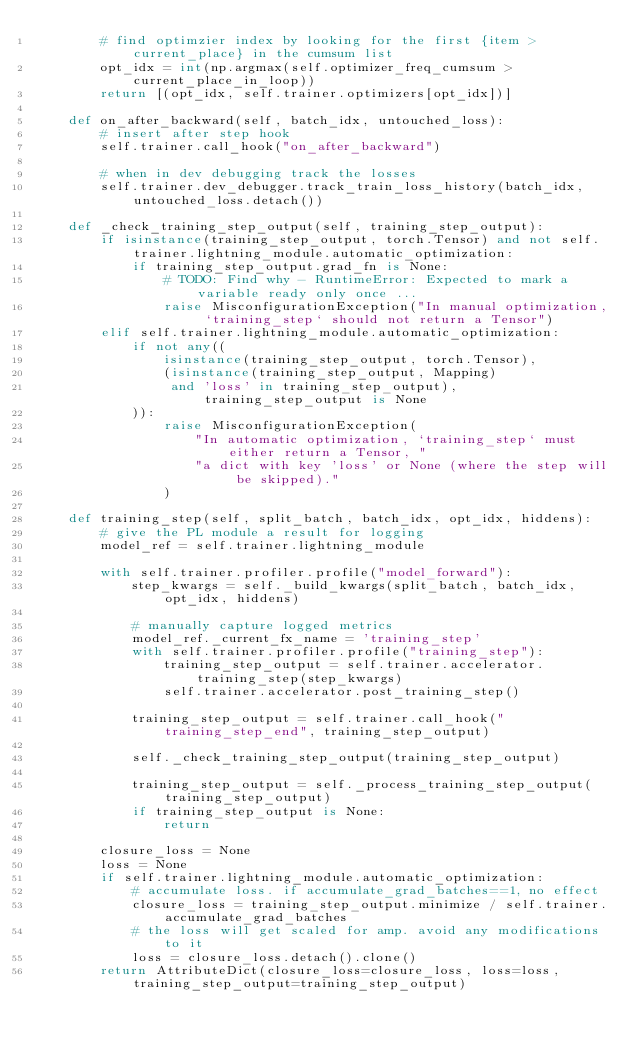Convert code to text. <code><loc_0><loc_0><loc_500><loc_500><_Python_>        # find optimzier index by looking for the first {item > current_place} in the cumsum list
        opt_idx = int(np.argmax(self.optimizer_freq_cumsum > current_place_in_loop))
        return [(opt_idx, self.trainer.optimizers[opt_idx])]

    def on_after_backward(self, batch_idx, untouched_loss):
        # insert after step hook
        self.trainer.call_hook("on_after_backward")

        # when in dev debugging track the losses
        self.trainer.dev_debugger.track_train_loss_history(batch_idx, untouched_loss.detach())

    def _check_training_step_output(self, training_step_output):
        if isinstance(training_step_output, torch.Tensor) and not self.trainer.lightning_module.automatic_optimization:
            if training_step_output.grad_fn is None:
                # TODO: Find why - RuntimeError: Expected to mark a variable ready only once ...
                raise MisconfigurationException("In manual optimization, `training_step` should not return a Tensor")
        elif self.trainer.lightning_module.automatic_optimization:
            if not any((
                isinstance(training_step_output, torch.Tensor),
                (isinstance(training_step_output, Mapping)
                 and 'loss' in training_step_output), training_step_output is None
            )):
                raise MisconfigurationException(
                    "In automatic optimization, `training_step` must either return a Tensor, "
                    "a dict with key 'loss' or None (where the step will be skipped)."
                )

    def training_step(self, split_batch, batch_idx, opt_idx, hiddens):
        # give the PL module a result for logging
        model_ref = self.trainer.lightning_module

        with self.trainer.profiler.profile("model_forward"):
            step_kwargs = self._build_kwargs(split_batch, batch_idx, opt_idx, hiddens)

            # manually capture logged metrics
            model_ref._current_fx_name = 'training_step'
            with self.trainer.profiler.profile("training_step"):
                training_step_output = self.trainer.accelerator.training_step(step_kwargs)
                self.trainer.accelerator.post_training_step()

            training_step_output = self.trainer.call_hook("training_step_end", training_step_output)

            self._check_training_step_output(training_step_output)

            training_step_output = self._process_training_step_output(training_step_output)
            if training_step_output is None:
                return

        closure_loss = None
        loss = None
        if self.trainer.lightning_module.automatic_optimization:
            # accumulate loss. if accumulate_grad_batches==1, no effect
            closure_loss = training_step_output.minimize / self.trainer.accumulate_grad_batches
            # the loss will get scaled for amp. avoid any modifications to it
            loss = closure_loss.detach().clone()
        return AttributeDict(closure_loss=closure_loss, loss=loss, training_step_output=training_step_output)
</code> 